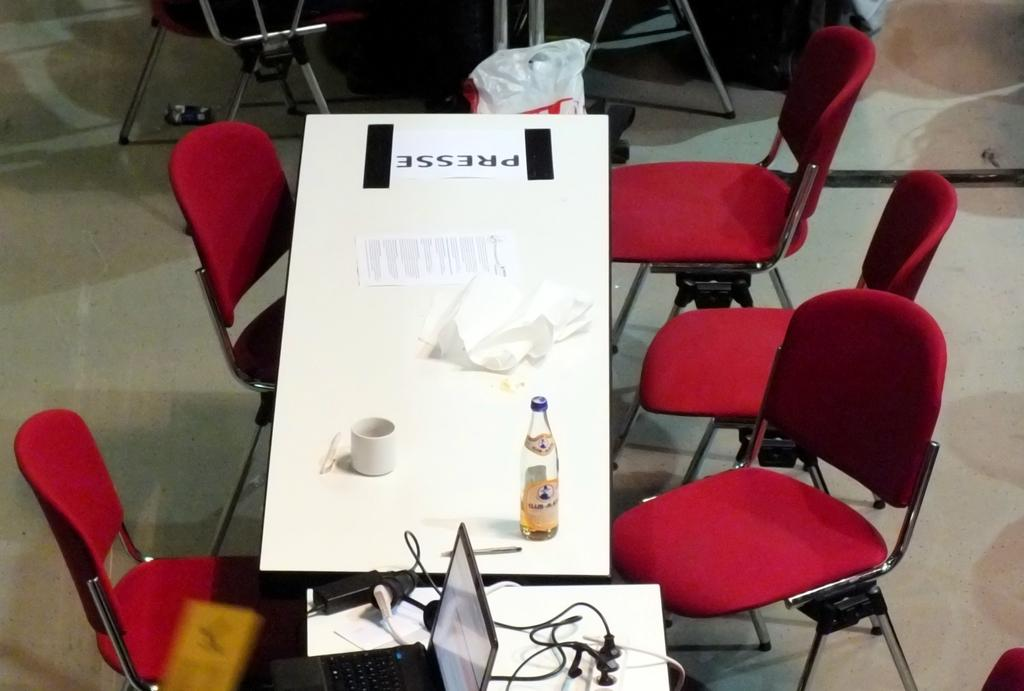What type of furniture is present in the image? There is a table in the image. Are there any chairs around the table? Yes, there are chairs around the table. What electronic device can be seen on the table? There is a laptop on the table. What else is on the table besides the laptop? There is a bottle on the table. Can you hear the whistle of the horses in the image? There are no horses or whistles present in the image. 